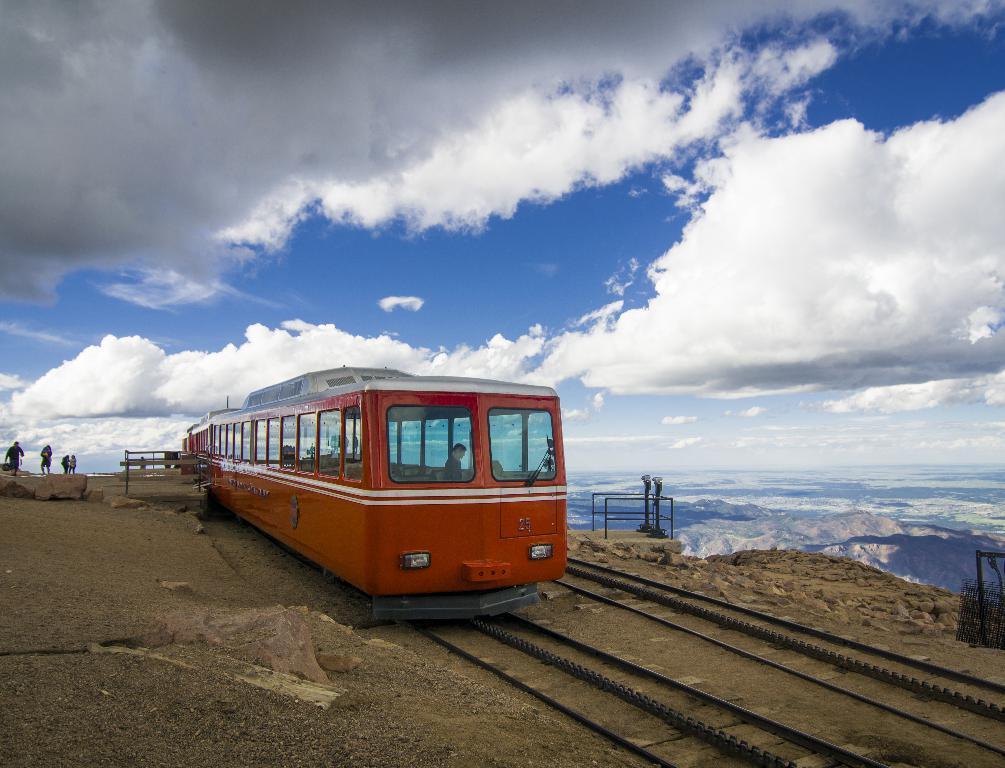Could you give a brief overview of what you see in this image? In the center of the image we can see a train on the railway track. On the left side of the image there are persons and rocks. In the background there are hills, sky and clouds. 